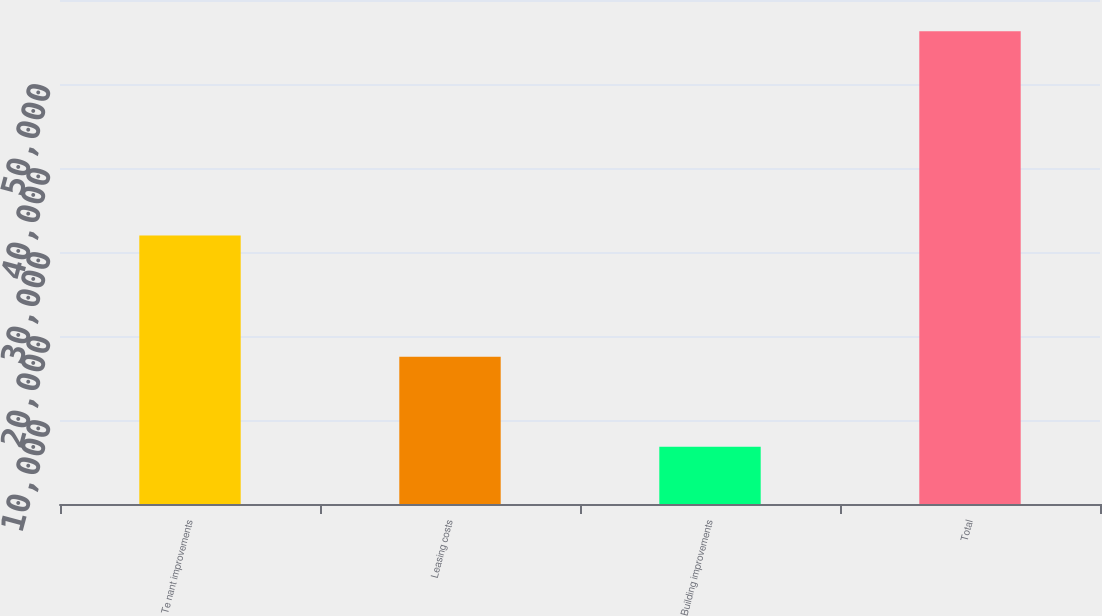<chart> <loc_0><loc_0><loc_500><loc_500><bar_chart><fcel>Te nant improvements<fcel>Leasing costs<fcel>Building improvements<fcel>Total<nl><fcel>31955<fcel>17530<fcel>6804<fcel>56289<nl></chart> 